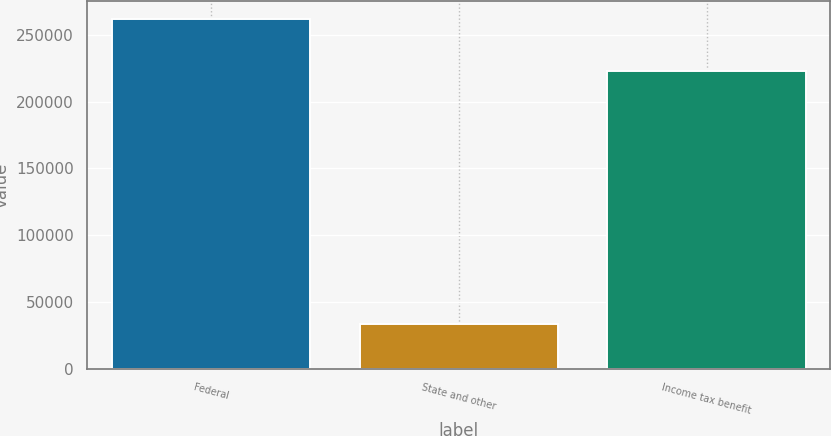<chart> <loc_0><loc_0><loc_500><loc_500><bar_chart><fcel>Federal<fcel>State and other<fcel>Income tax benefit<nl><fcel>261921<fcel>33729<fcel>222486<nl></chart> 